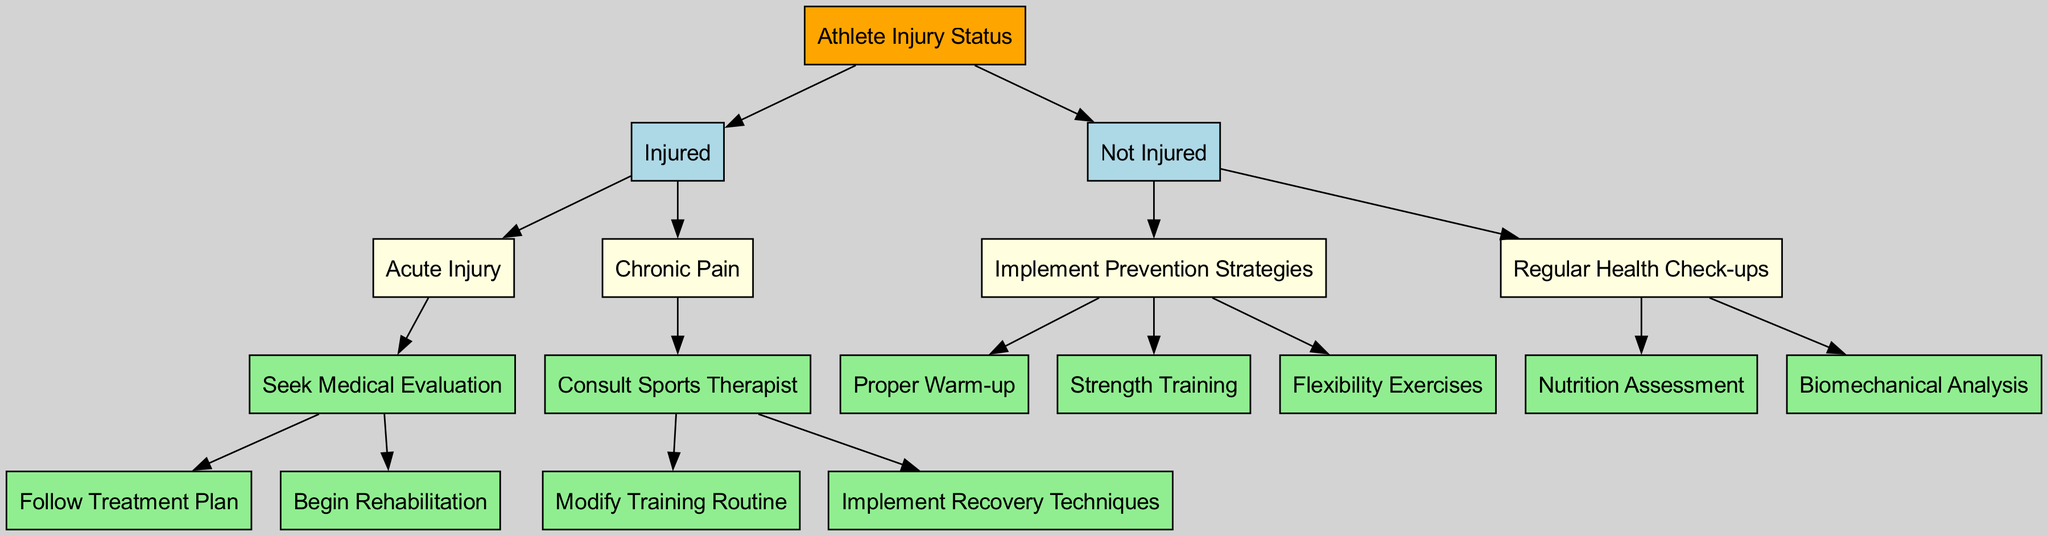What is the root node of the diagram? The root node is "Athlete Injury Status," which serves as the central point of the decision tree from which other nodes branch out.
Answer: Athlete Injury Status How many main branches are there from the root node? There are two main branches stemming from the root node: "Injured" and "Not Injured," representing different athlete injury statuses.
Answer: 2 What is the first action for an acute injury? For an acute injury, the diagram indicates that the first action is to "Seek Medical Evaluation," which is critical for determining the next steps in treatment.
Answer: Seek Medical Evaluation What should an athlete do if they are not injured? If not injured, athletes should "Implement Prevention Strategies" to maintain their health and prevent future injuries.
Answer: Implement Prevention Strategies If an athlete is experiencing chronic pain, what professional should they consult? The diagram clearly states that an athlete with chronic pain should "Consult Sports Therapist," indicating the specialized support needed for recovery.
Answer: Consult Sports Therapist Which two recovery strategies follow after consulting a sports therapist? After consulting a sports therapist, the two strategies mentioned are "Modify Training Routine" and "Implement Recovery Techniques," which can facilitate recovery and enhance performance.
Answer: Modify Training Routine, Implement Recovery Techniques What is one example of a prevention strategy for athletes? One specific prevention strategy highlighted in the diagram is "Proper Warm-up," which is essential for preparing the body and preventing injuries during training and competition.
Answer: Proper Warm-up What analysis can be performed during regular health check-ups? The diagram mentions "Biomechanical Analysis" as part of the regular health check-ups, helping to identify any potential areas of concern that could lead to injuries.
Answer: Biomechanical Analysis How many children nodes does the "Injured" node have? The "Injured" node has two children nodes: "Acute Injury" and "Chronic Pain," which categorize injury types for targeted approaches.
Answer: 2 